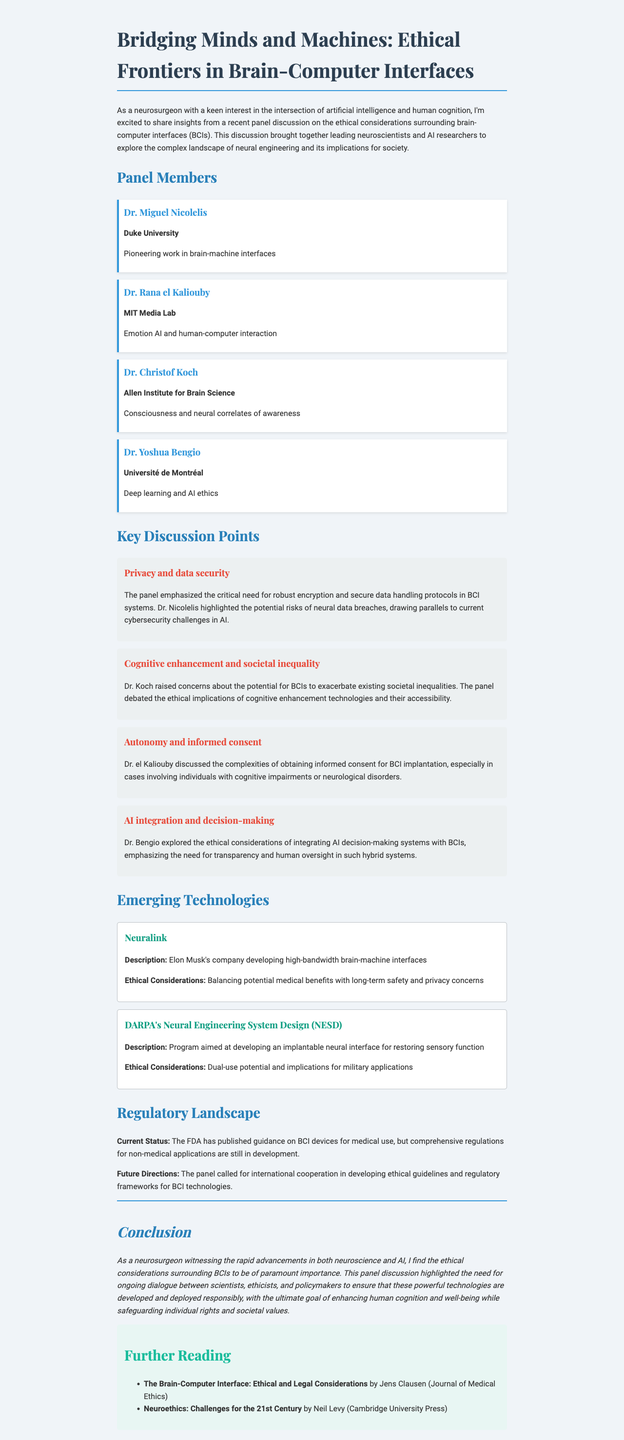What is the title of the newsletter? The title of the newsletter is explicitly displayed at the beginning of the document.
Answer: Bridging Minds and Machines: Ethical Frontiers in Brain-Computer Interfaces Who is the first panel member listed? The first panel member listed in the document under the "Panel Members" section is named at the top of that section.
Answer: Dr. Miguel Nicolelis What ethical consideration did Dr. Koch raise? Dr. Koch's contribution to the discussion is summarized under the key points, focusing on societal issues related to BCIs.
Answer: Cognitive enhancement and societal inequality Which institution is Dr. Bengio affiliated with? Dr. Bengio's affiliation is mentioned alongside his name in the "Panel Members" section of the document.
Answer: Université de Montréal What is Neuralink developing? The description of Neuralink is provided in the "Emerging Technologies" section, specifying its goals.
Answer: High-bandwidth brain-machine interfaces What does the FDA currently have regarding BCI devices? The status of regulations provided indicates the existence of FDA guidance related to BCI devices.
Answer: Published guidance What is the primary concern regarding privacy and data security? The summary under key discussion points highlights the critical need discussed by the panel in relation to BCI systems.
Answer: Robust encryption and secure data handling protocols Which publication is recommended for further reading? The "Further Reading" section lists titles, including those focusing on ethical considerations and neuroethics.
Answer: The Brain-Computer Interface: Ethical and Legal Considerations What is the future direction mentioned for BCI regulations? The document summarizes a call made by the panel for future actions related to BCI regulatory frameworks.
Answer: International cooperation in developing ethical guidelines 